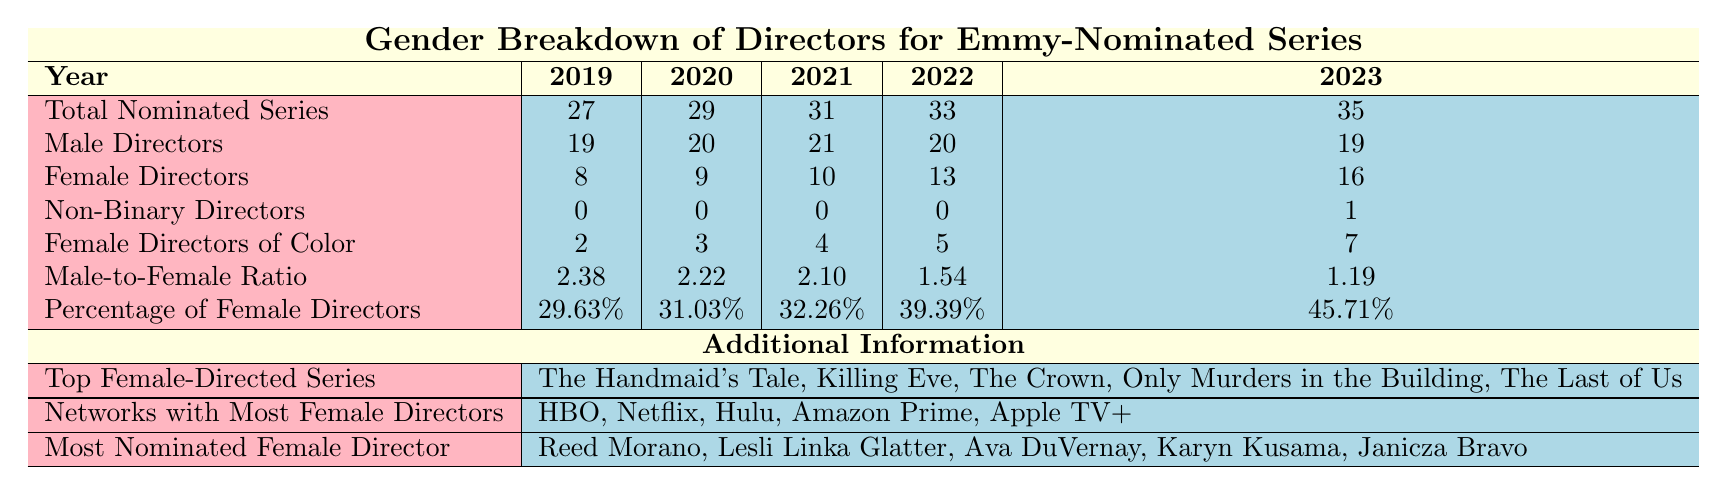What was the percentage of female directors in 2023? The table states that in 2023, the percentage of female directors is 45.71%.
Answer: 45.71% How many female directors were nominated in 2021? According to the table, there were 10 female directors nominated in 2021.
Answer: 10 What is the male-to-female ratio for directors in 2022? The table indicates that the male-to-female ratio for directors in 2022 is 1.54.
Answer: 1.54 Which year had the highest number of female directors nominated? By looking at the female directors' counts, 2023 had 16 female directors, which is the highest compared to previous years.
Answer: 2023 Did the number of non-binary directors increase from 2022 to 2023? Yes, in 2022 there were 0 non-binary directors, and in 2023, there was 1 non-binary director.
Answer: Yes What is the total number of directors (male + female + non-binary) nominated in 2020? The total number of directors in 2020 is calculated as 20 (male) + 9 (female) + 0 (non-binary) = 29.
Answer: 29 What is the difference in the number of female directors between 2019 and 2023? To find the difference, subtract the number of female directors in 2019 (8) from the number in 2023 (16), resulting in 16 - 8 = 8.
Answer: 8 In which year did the percentage of female directors first exceed 30%? Checking the percentages, the first year to exceed 30% was 2020, with a percentage of 31.03%.
Answer: 2020 What are the names of the networks that had the most female directors in 2021? The table lists the networks with the most female directors, which are the same across all years: HBO, Netflix, Hulu, Amazon Prime, and Apple TV+.
Answer: HBO, Netflix, Hulu, Amazon Prime, Apple TV+ Which female director directed the most Emmy-nominated series in 2022? According to the table, Karyn Kusama was the most nominated female director in 2022.
Answer: Karyn Kusama What is the increase in the number of female directors of color from 2020 to 2023? The increase is calculated by subtracting the number of female directors of color in 2020 (3) from the number in 2023 (7), which equals 7 - 3 = 4.
Answer: 4 